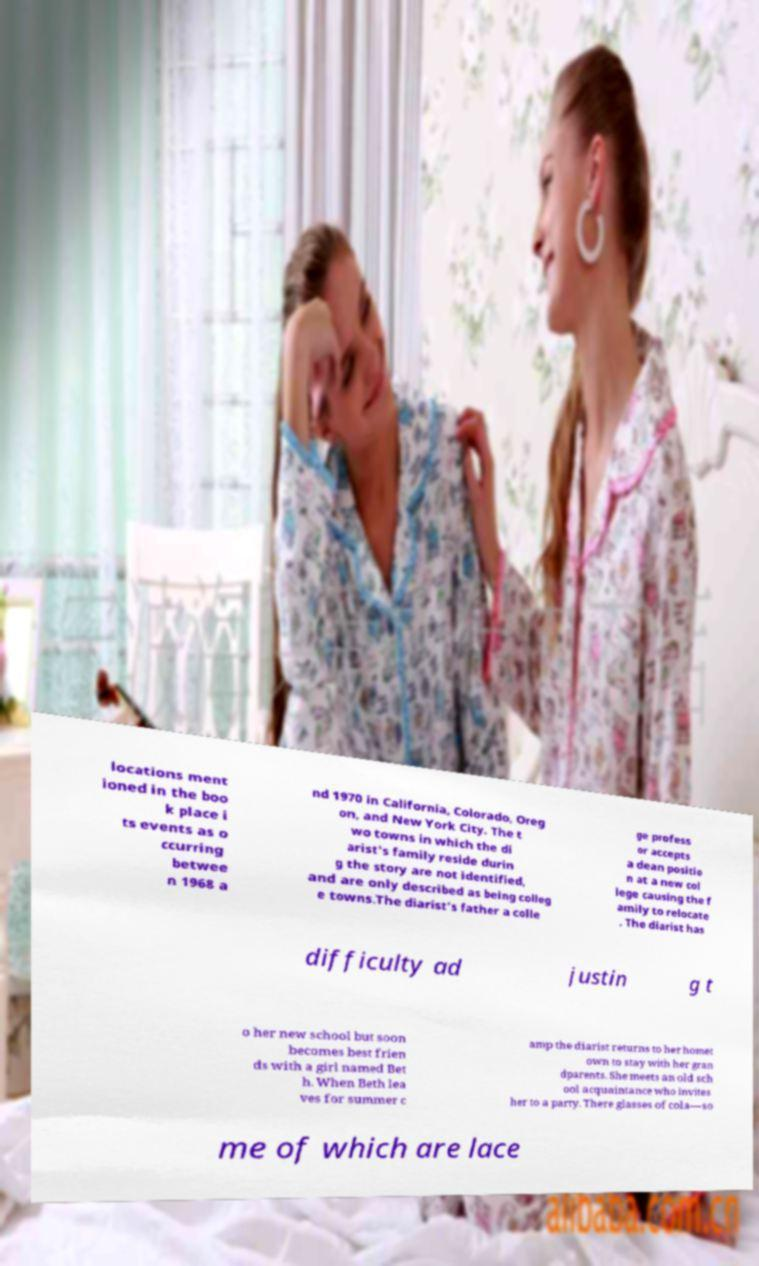Could you assist in decoding the text presented in this image and type it out clearly? locations ment ioned in the boo k place i ts events as o ccurring betwee n 1968 a nd 1970 in California, Colorado, Oreg on, and New York City. The t wo towns in which the di arist's family reside durin g the story are not identified, and are only described as being colleg e towns.The diarist's father a colle ge profess or accepts a dean positio n at a new col lege causing the f amily to relocate . The diarist has difficulty ad justin g t o her new school but soon becomes best frien ds with a girl named Bet h. When Beth lea ves for summer c amp the diarist returns to her homet own to stay with her gran dparents. She meets an old sch ool acquaintance who invites her to a party. There glasses of cola—so me of which are lace 